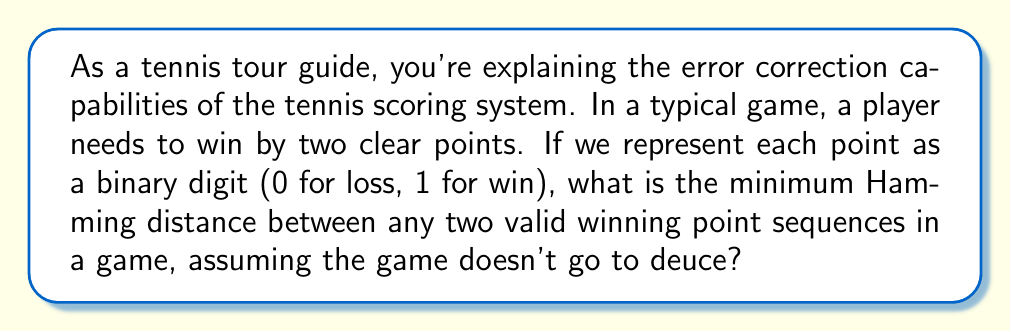Solve this math problem. To solve this problem, let's break it down step-by-step:

1) In a standard tennis game (not going to deuce), a player needs to win at least 4 points and be ahead by 2 to win the game. The possible winning sequences are:

   4-0: 1111
   4-1: 11101
   4-2: 111001

2) The Hamming distance is the number of positions at which the corresponding symbols in two strings of equal length are different.

3) To find the minimum Hamming distance, we need to compare these sequences:

   1111 vs 11101: Different in 1 position
   1111 vs 111001: Different in 2 positions
   11101 vs 111001: Different in 2 positions

4) The minimum difference we see is 1, but this is not the correct answer. Here's why:

5) In information theory, the Hamming distance represents the number of errors that can be detected or corrected. A Hamming distance of 1 would mean no error detection is possible.

6) However, in tennis scoring, a single point error would never result in a wrong game outcome. This is because:
   - If the true score is 4-0 and one point is recorded wrongly, it becomes 3-1, which is not a winning score.
   - If the true score is 4-1 and one point is recorded wrongly, it becomes either 3-1 or 4-0, neither of which would end the game incorrectly.
   - The same logic applies to 4-2.

7) In fact, it always takes at least two point errors to potentially change the outcome of a game incorrectly.

8) Therefore, the actual minimum Hamming distance that represents the error correction capability of the tennis scoring system is 2.

This means the tennis scoring system can always detect up to 1 error and correct up to $\lfloor \frac{2-1}{2} \rfloor = 0$ errors, which aligns with the practical implementation of the scoring system.
Answer: The minimum Hamming distance is 2. 